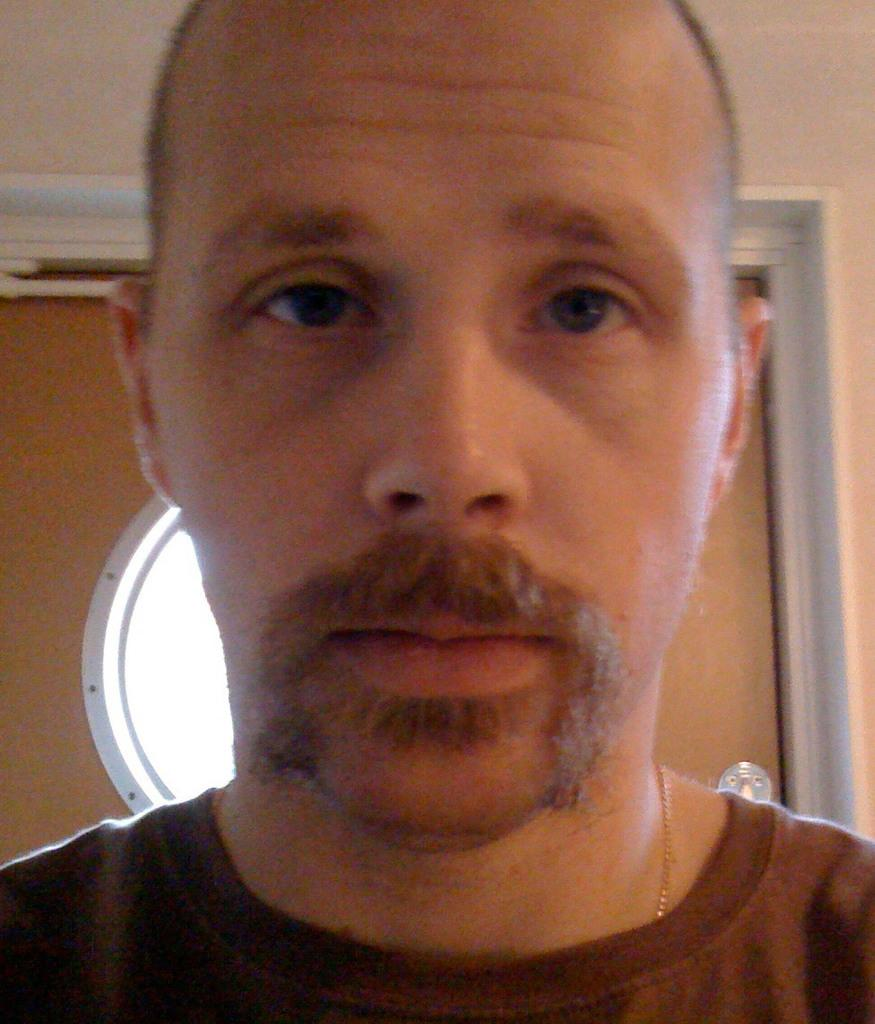Who is the main subject in the image? There is a man in the center of the image. What can be seen in the background of the image? There is a wall and a door in the background of the image. What type of feather is being used by the man in the image? There is no feather present in the image; the man is not using any feather. 